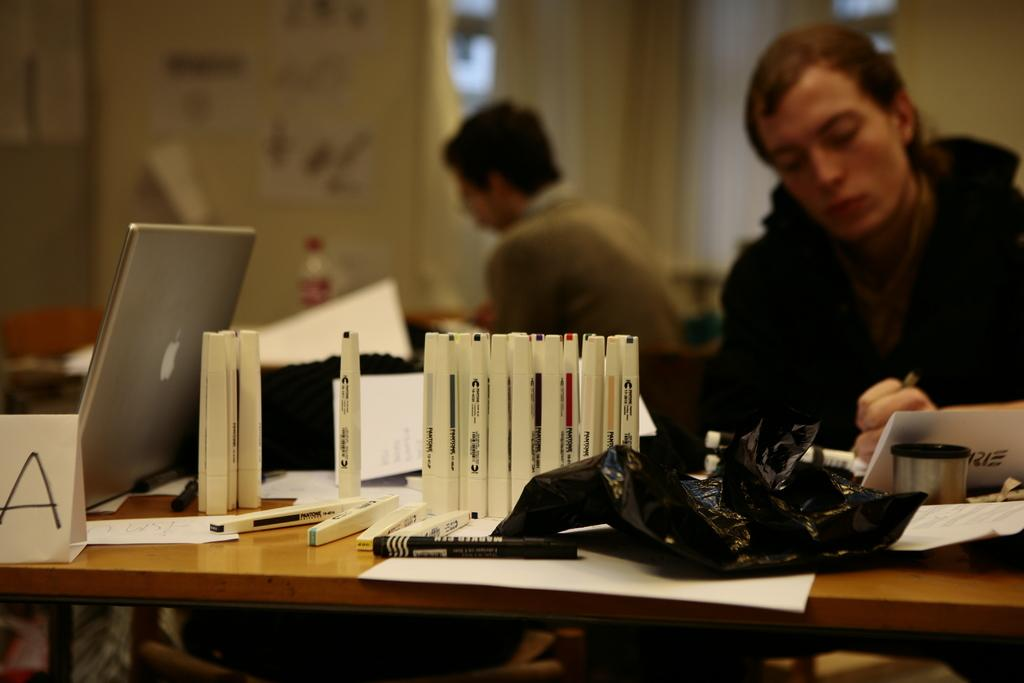What is the main piece of furniture in the image? There is a table in the image. What items can be seen on the table? There are markers, a laptop, a card, papers, and unspecified "things" on the table. Can you describe the background of the image? The background of the image is blurred. Are there any people visible in the image? Yes, there are people visible in the image. What is the man holding in the image? The man is holding a pen. What can be seen on the wall in the image? There are posters on the wall. What type of butter is being spread on the spoon in the image? There is no spoon or butter present in the image. How fast are the people running in the image? There is no indication of anyone running in the image. 